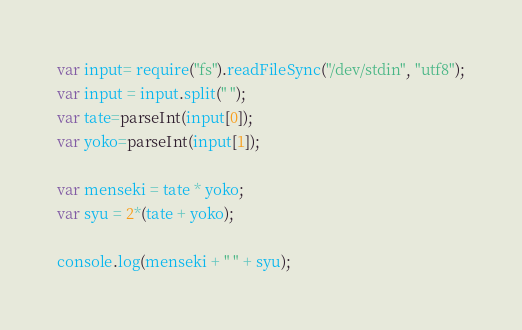Convert code to text. <code><loc_0><loc_0><loc_500><loc_500><_JavaScript_>var input= require("fs").readFileSync("/dev/stdin", "utf8");
var input = input.split(" ");
var tate=parseInt(input[0]);
var yoko=parseInt(input[1]);

var menseki = tate * yoko;
var syu = 2*(tate + yoko); 

console.log(menseki + " " + syu);
</code> 